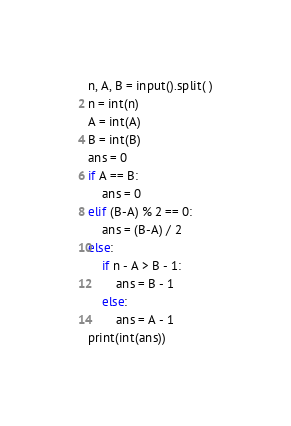<code> <loc_0><loc_0><loc_500><loc_500><_Python_>n, A, B = input().split( )
n = int(n)
A = int(A)
B = int(B)
ans = 0
if A == B:
    ans = 0
elif (B-A) % 2 == 0:
    ans = (B-A) / 2
else:
    if n - A > B - 1:
        ans = B - 1
    else:
        ans = A - 1
print(int(ans))</code> 